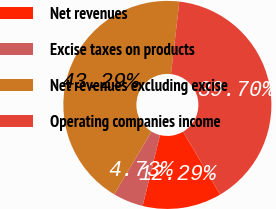Convert chart to OTSL. <chart><loc_0><loc_0><loc_500><loc_500><pie_chart><fcel>Net revenues<fcel>Excise taxes on products<fcel>Net revenues excluding excise<fcel>Operating companies income<nl><fcel>12.29%<fcel>4.73%<fcel>43.29%<fcel>39.7%<nl></chart> 